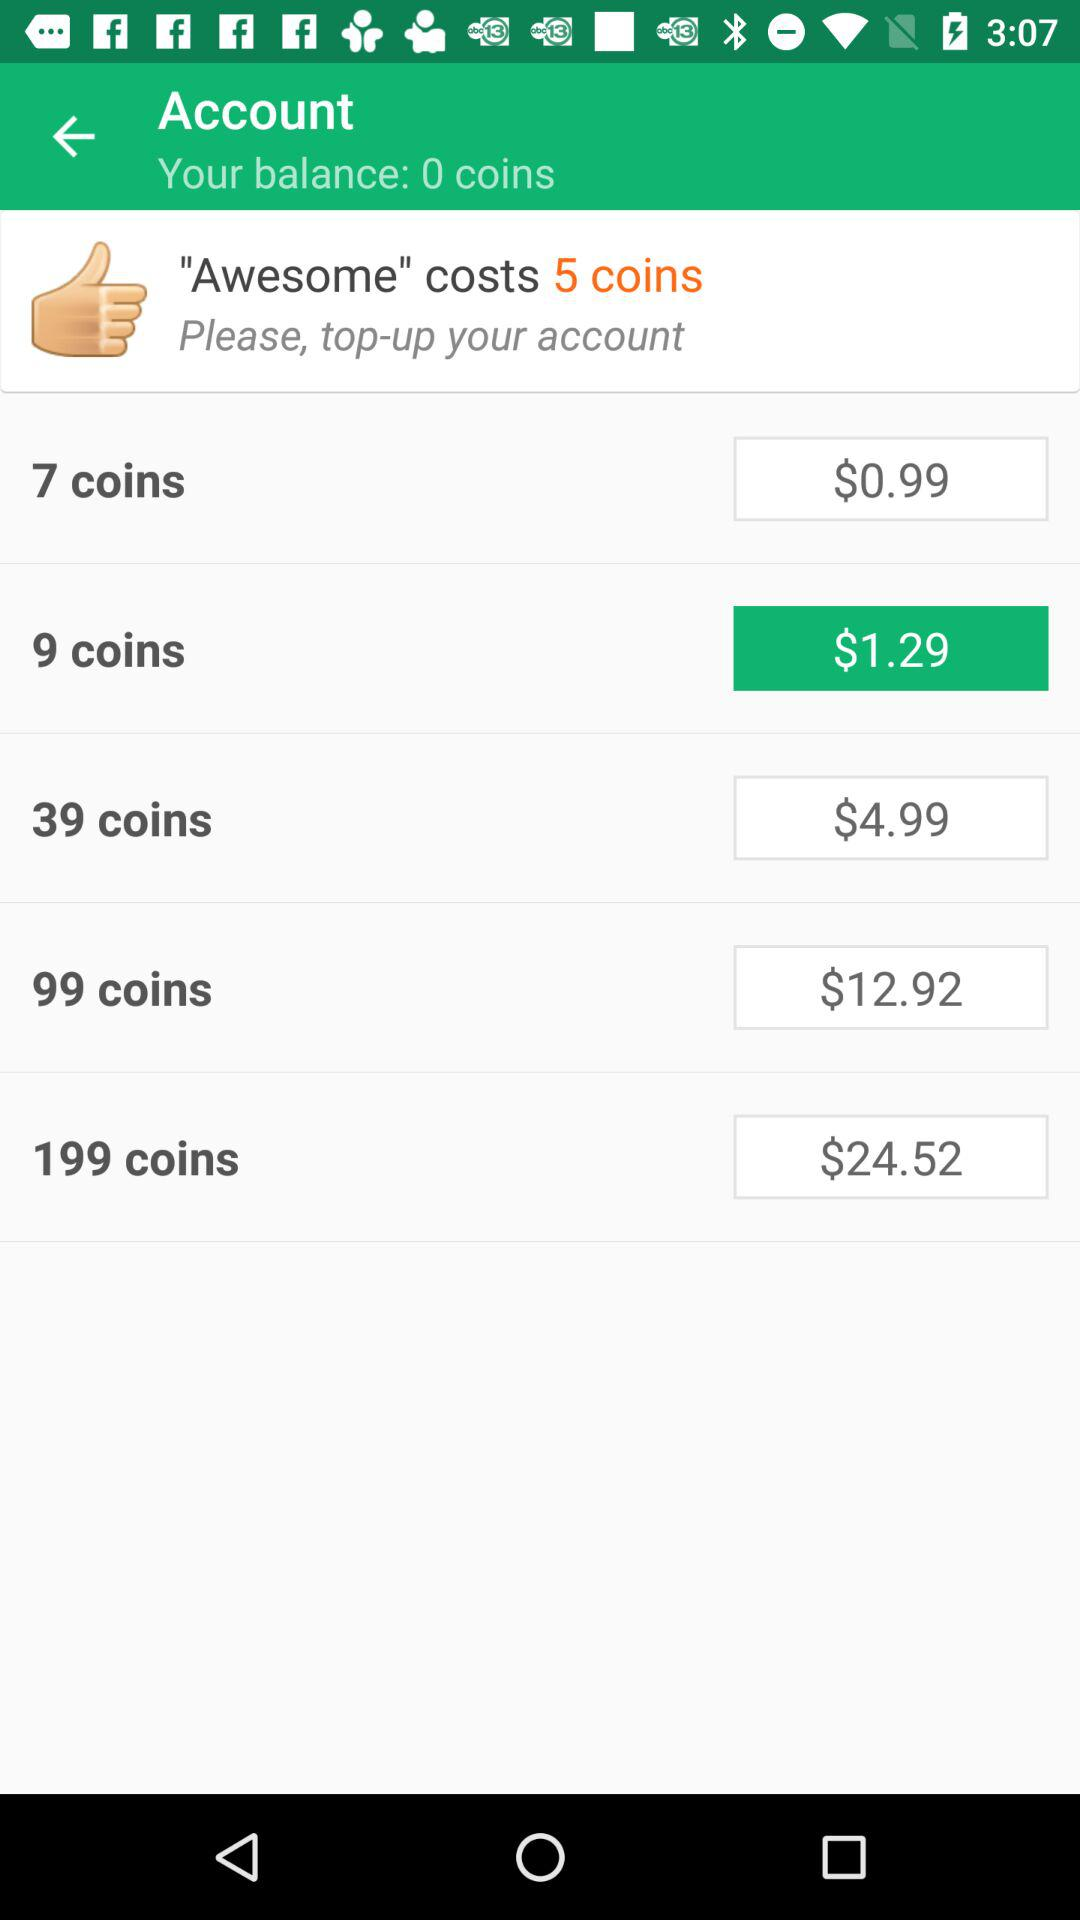How much is the price to buy 199 coins? The price is $24.52. 